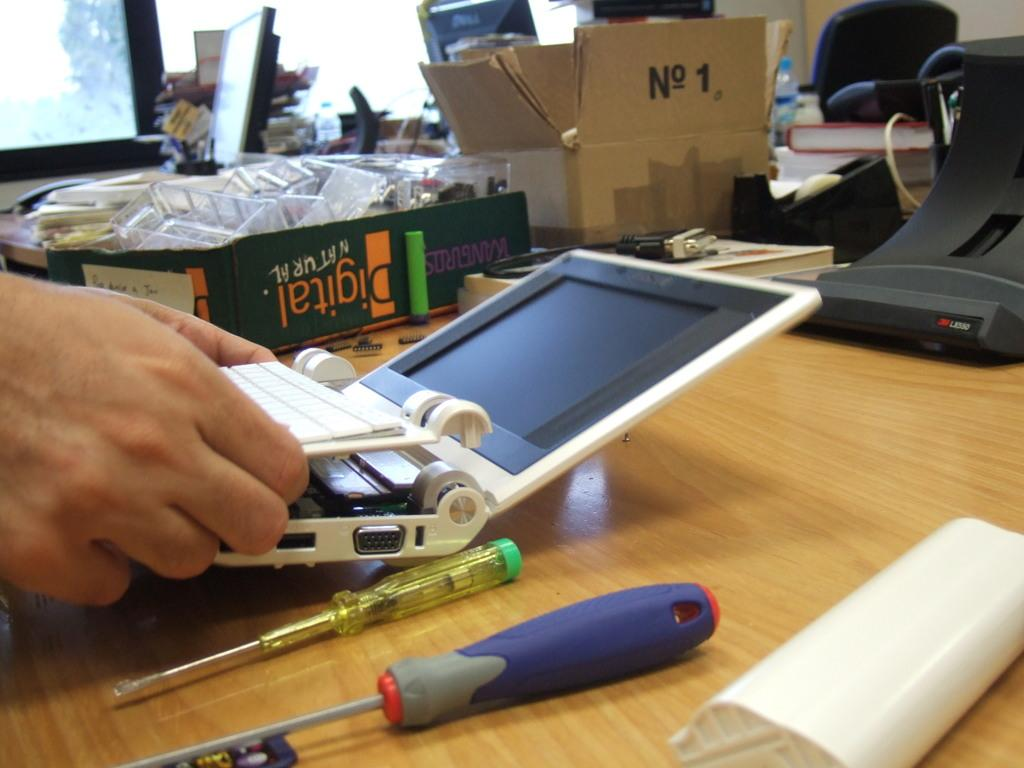<image>
Relay a brief, clear account of the picture shown. A tech repairman putting a broken netbook back together 